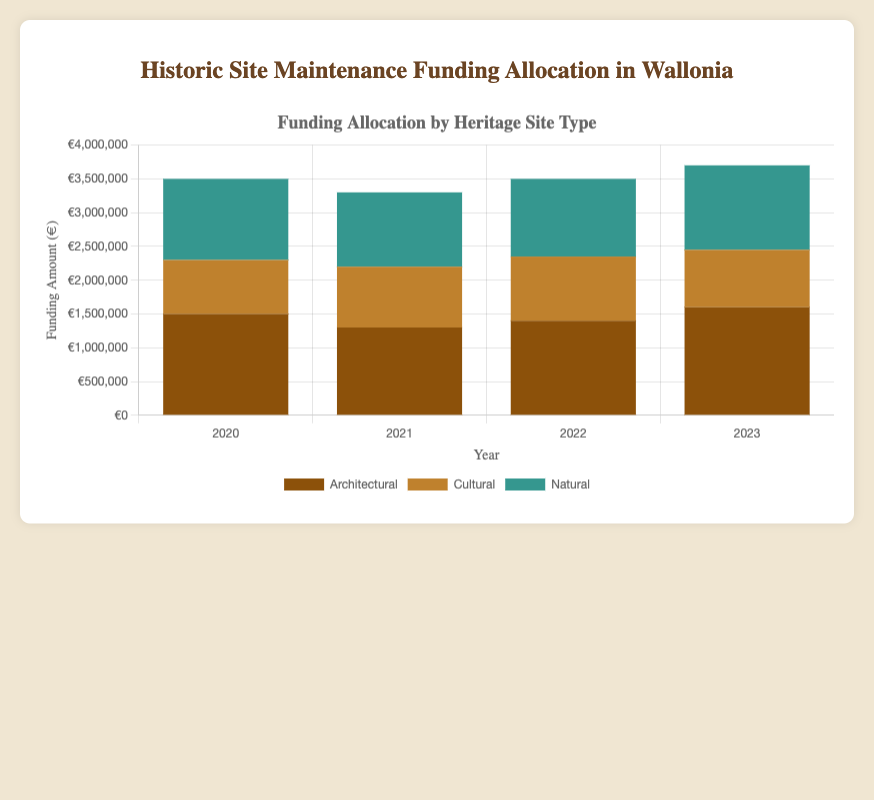Which year had the highest total funding allocation? To find the highest total funding allocation, sum the funding amounts for all site types in each year and compare them. For 2020, the total is €3,500,000; for 2021, the total is €3,300,000; for 2022, the total is €3,500,000; for 2023, the total is €3,700,000. Therefore, 2023 had the highest total funding allocation.
Answer: 2023 How much more funding was allocated to natural sites than cultural sites in 2023? Look at the figures for natural and cultural sites in 2023. Natural sites received €1,250,000, and cultural sites received €850,000. Subtract the cultural funding from the natural funding: €1,250,000 - €850,000 = €400,000.
Answer: €400,000 What is the average funding amount per year for architectural sites? To find the average funding for architectural sites, sum the funding amounts over all years and divide by the number of years. The total funding is €1,500,000 + €1,300,000 + €1,400,000 + €1,600,000 = €5,800,000. There are 4 years, so the average is €5,800,000 / 4 = €1,450,000.
Answer: €1,450,000 Which site type had the least variation in funding amounts over the years? Compare the range (difference between the highest and lowest values) of the funding amounts for each site type. Architectural funding ranges from €1,300,000 to €1,600,000 (variation of €300,000). Cultural funding ranges from €800,000 to €950,000 (variation of €150,000). Natural funding ranges from €1,100,000 to €1,250,000 (variation of €150,000). Therefore, cultural and natural sites both had the least variation (€150,000).
Answer: Cultural and Natural Was there a significant change in funding for architectural sites between 2021 and 2022? Compare the funding amounts for architectural sites in 2021 (€1,300,000) and 2022 (€1,400,000). The change is €1,400,000 - €1,300,000 = €100,000. While this is not a dramatic change, it is a notable increase.
Answer: No significant change What is the total funding received by cultural sites over the four years? Sum the funding amounts for cultural sites from each year: €800,000 + €900,000 + €950,000 + €850,000 = €3,500,000.
Answer: €3,500,000 Based on the visual colors, which site type has been consistently funded the highest in recent years? The colors for architectural sites (brown), cultural sites (orange), and natural sites (teal). From the heights of the stacked bars, natural sites generally have the highest funding amounts in the recent years, though architectural funding surpasses in 2023. Natural sites have had notably high funding consistently in most years.
Answer: Natural sites Which year's funding allocation had the largest disparity between any two site types? Calculate the disparity for each year by finding the maximum difference in funding amounts between any two site types. In 2020: max difference is €1,500,000 - €800,000 = €700,000; in 2021: €1,300,000 - €900,000 = €400,000; in 2022: €1,400,000 - €950,000 = €450,000; in 2023: €1,600,000 - €850,000 = €750,000; the largest disparity is in 2023 with €750,000.
Answer: 2023 What were the funding trends for cultural sites over the four years? Examine the funding amounts for cultural sites across the years: €800,000 in 2020, €900,000 in 2021, €950,000 in 2022, and €850,000 in 2023. The trend shows an initial increase from 2020 to 2022, followed by a slight decrease in 2023.
Answer: Increasing then decreasing 